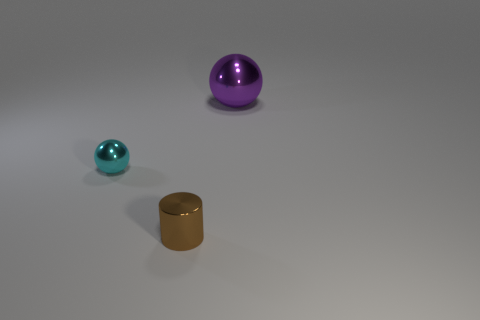Add 2 tiny red rubber things. How many objects exist? 5 Subtract 1 balls. How many balls are left? 1 Subtract all cyan spheres. How many spheres are left? 1 Subtract all balls. How many objects are left? 1 Subtract all red cylinders. Subtract all large purple objects. How many objects are left? 2 Add 3 large purple spheres. How many large purple spheres are left? 4 Add 1 purple shiny spheres. How many purple shiny spheres exist? 2 Subtract 0 cyan blocks. How many objects are left? 3 Subtract all red balls. Subtract all cyan cylinders. How many balls are left? 2 Subtract all yellow cubes. How many purple spheres are left? 1 